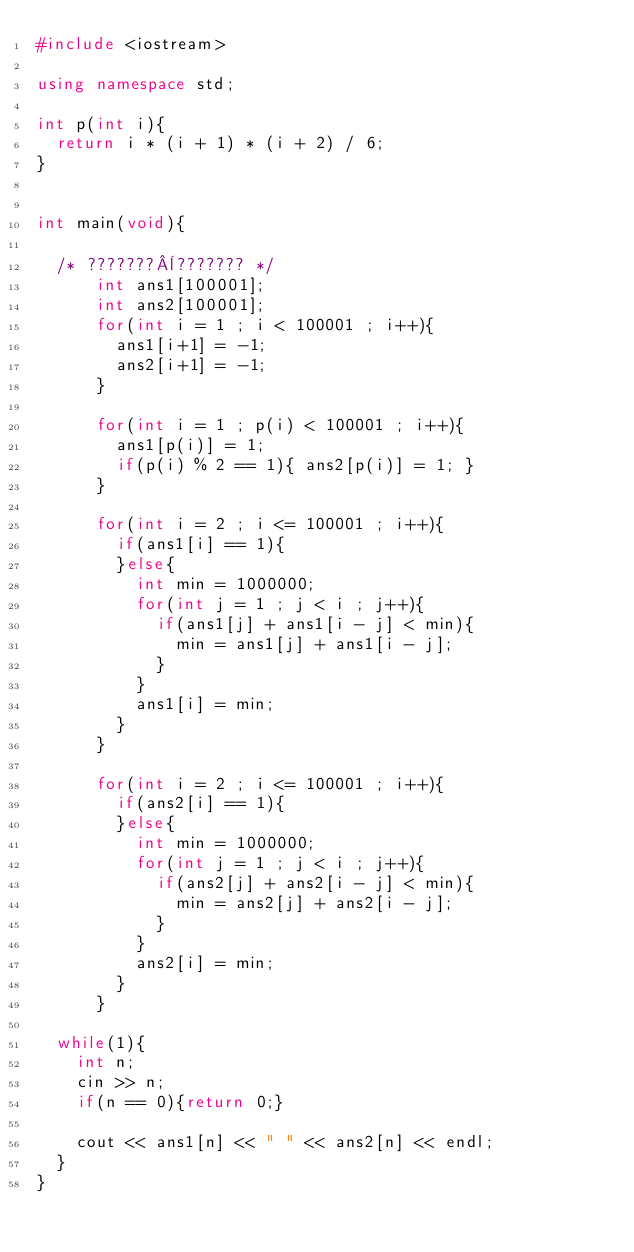Convert code to text. <code><loc_0><loc_0><loc_500><loc_500><_C++_>#include <iostream>

using namespace std;

int p(int i){
  return i * (i + 1) * (i + 2) / 6;
}


int main(void){

  /* ???????¨??????? */
      int ans1[100001];
      int ans2[100001];
      for(int i = 1 ; i < 100001 ; i++){
        ans1[i+1] = -1;
        ans2[i+1] = -1;
      }

      for(int i = 1 ; p(i) < 100001 ; i++){
        ans1[p(i)] = 1;
        if(p(i) % 2 == 1){ ans2[p(i)] = 1; }
      }

      for(int i = 2 ; i <= 100001 ; i++){
        if(ans1[i] == 1){
        }else{
          int min = 1000000;
          for(int j = 1 ; j < i ; j++){
            if(ans1[j] + ans1[i - j] < min){
              min = ans1[j] + ans1[i - j];
            }
          }
          ans1[i] = min;
        }
      }

      for(int i = 2 ; i <= 100001 ; i++){
        if(ans2[i] == 1){
        }else{
          int min = 1000000;
          for(int j = 1 ; j < i ; j++){
            if(ans2[j] + ans2[i - j] < min){
              min = ans2[j] + ans2[i - j];
            }
          }
          ans2[i] = min;
        }
      }

  while(1){
    int n;
    cin >> n;
    if(n == 0){return 0;}

    cout << ans1[n] << " " << ans2[n] << endl;
  }
}</code> 